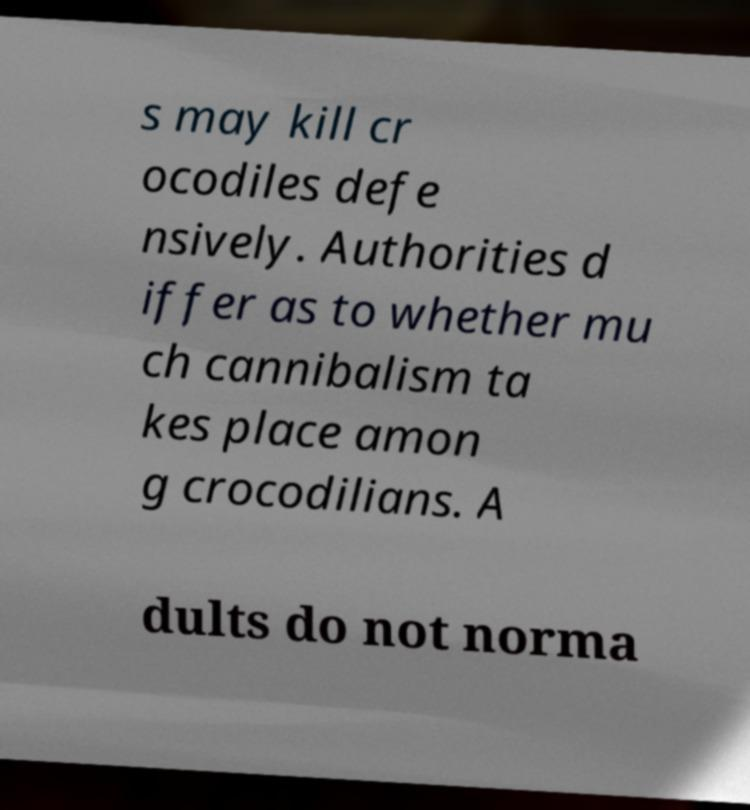Could you assist in decoding the text presented in this image and type it out clearly? s may kill cr ocodiles defe nsively. Authorities d iffer as to whether mu ch cannibalism ta kes place amon g crocodilians. A dults do not norma 